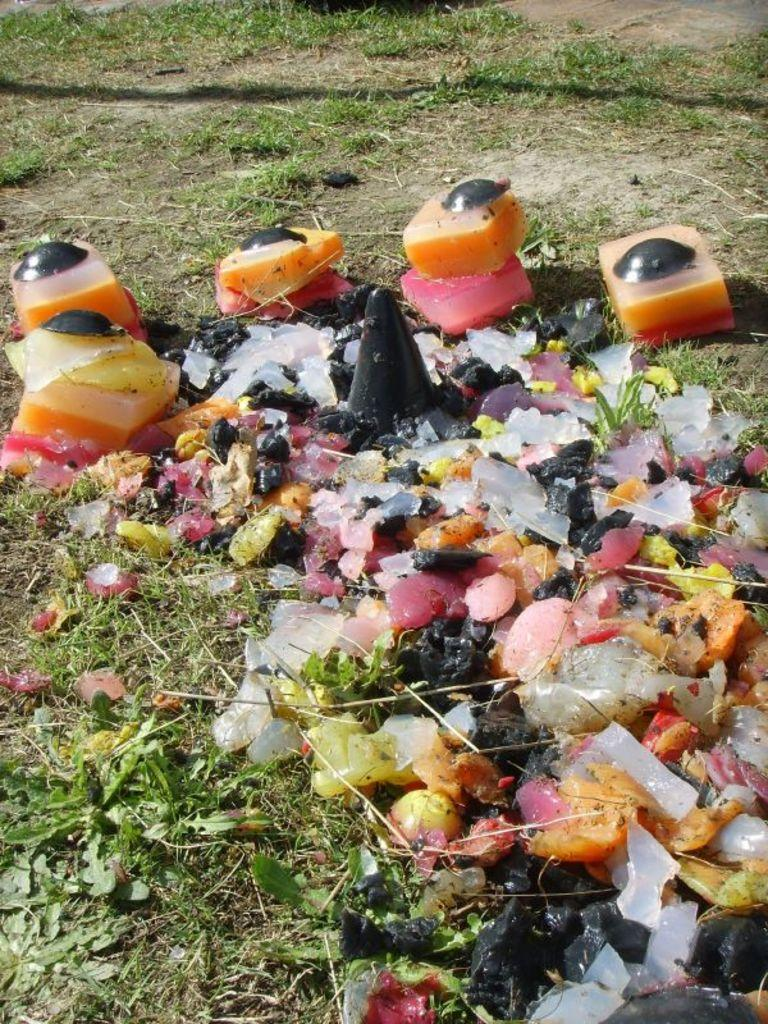What is present on the ground in the image? There is garbage and grass on the ground in the image. Can you describe the type of vegetation present in the image? The vegetation present in the image is grass. What type of chalk is being used by the woman in the image? There is no woman present in the image, and therefore no chalk or chalk-related activity can be observed. 